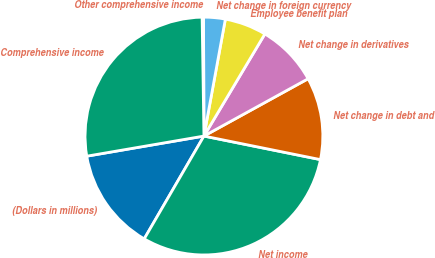Convert chart. <chart><loc_0><loc_0><loc_500><loc_500><pie_chart><fcel>(Dollars in millions)<fcel>Net income<fcel>Net change in debt and<fcel>Net change in derivatives<fcel>Employee benefit plan<fcel>Net change in foreign currency<fcel>Other comprehensive income<fcel>Comprehensive income<nl><fcel>13.92%<fcel>30.2%<fcel>11.18%<fcel>8.43%<fcel>5.68%<fcel>2.94%<fcel>0.19%<fcel>27.46%<nl></chart> 